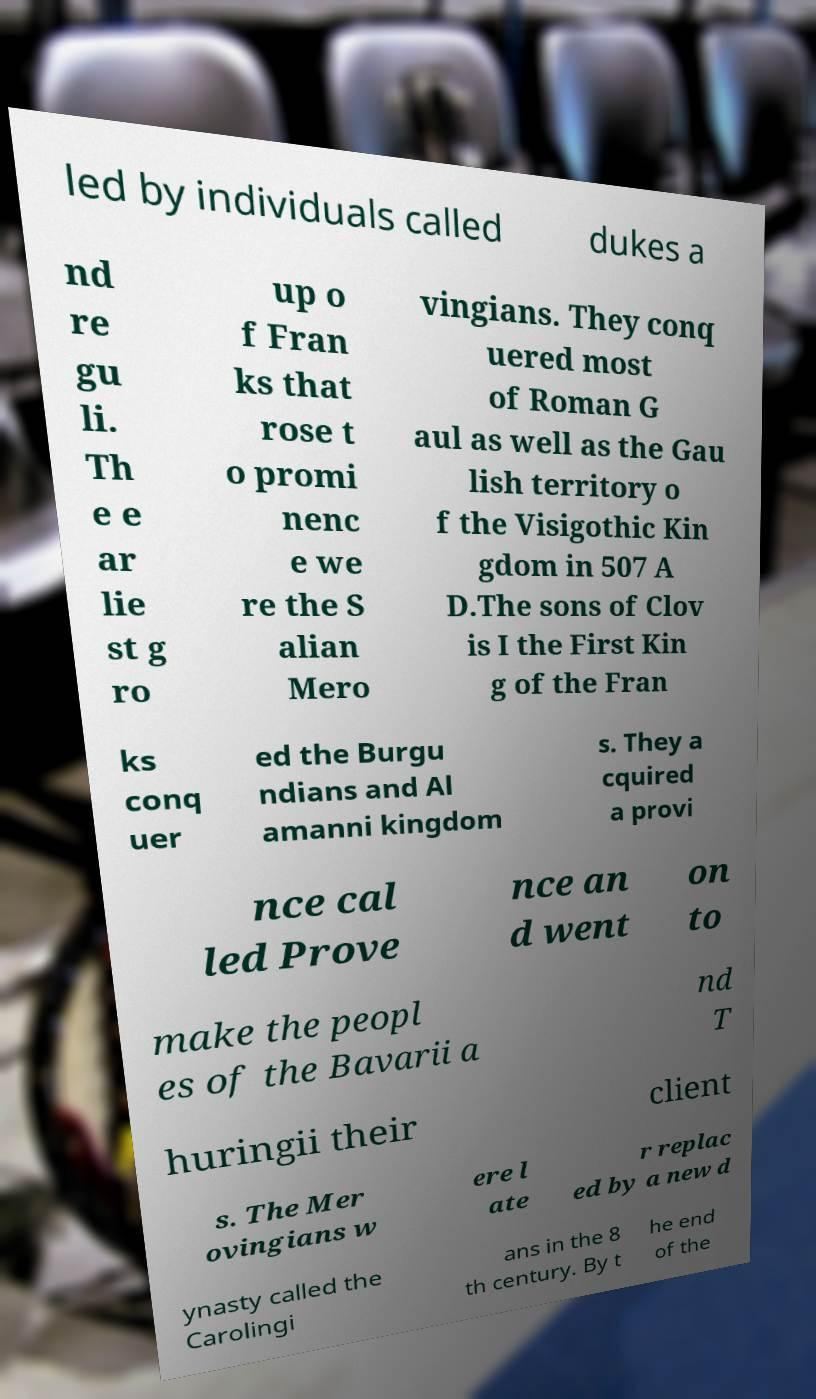Can you read and provide the text displayed in the image?This photo seems to have some interesting text. Can you extract and type it out for me? led by individuals called dukes a nd re gu li. Th e e ar lie st g ro up o f Fran ks that rose t o promi nenc e we re the S alian Mero vingians. They conq uered most of Roman G aul as well as the Gau lish territory o f the Visigothic Kin gdom in 507 A D.The sons of Clov is I the First Kin g of the Fran ks conq uer ed the Burgu ndians and Al amanni kingdom s. They a cquired a provi nce cal led Prove nce an d went on to make the peopl es of the Bavarii a nd T huringii their client s. The Mer ovingians w ere l ate r replac ed by a new d ynasty called the Carolingi ans in the 8 th century. By t he end of the 